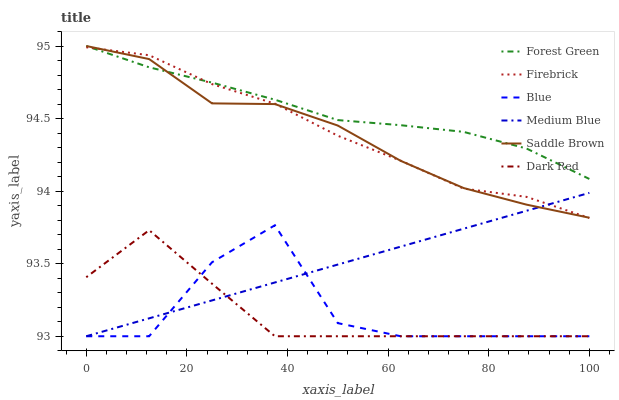Does Dark Red have the minimum area under the curve?
Answer yes or no. Yes. Does Forest Green have the maximum area under the curve?
Answer yes or no. Yes. Does Firebrick have the minimum area under the curve?
Answer yes or no. No. Does Firebrick have the maximum area under the curve?
Answer yes or no. No. Is Medium Blue the smoothest?
Answer yes or no. Yes. Is Blue the roughest?
Answer yes or no. Yes. Is Dark Red the smoothest?
Answer yes or no. No. Is Dark Red the roughest?
Answer yes or no. No. Does Blue have the lowest value?
Answer yes or no. Yes. Does Firebrick have the lowest value?
Answer yes or no. No. Does Saddle Brown have the highest value?
Answer yes or no. Yes. Does Firebrick have the highest value?
Answer yes or no. No. Is Dark Red less than Saddle Brown?
Answer yes or no. Yes. Is Firebrick greater than Blue?
Answer yes or no. Yes. Does Forest Green intersect Saddle Brown?
Answer yes or no. Yes. Is Forest Green less than Saddle Brown?
Answer yes or no. No. Is Forest Green greater than Saddle Brown?
Answer yes or no. No. Does Dark Red intersect Saddle Brown?
Answer yes or no. No. 